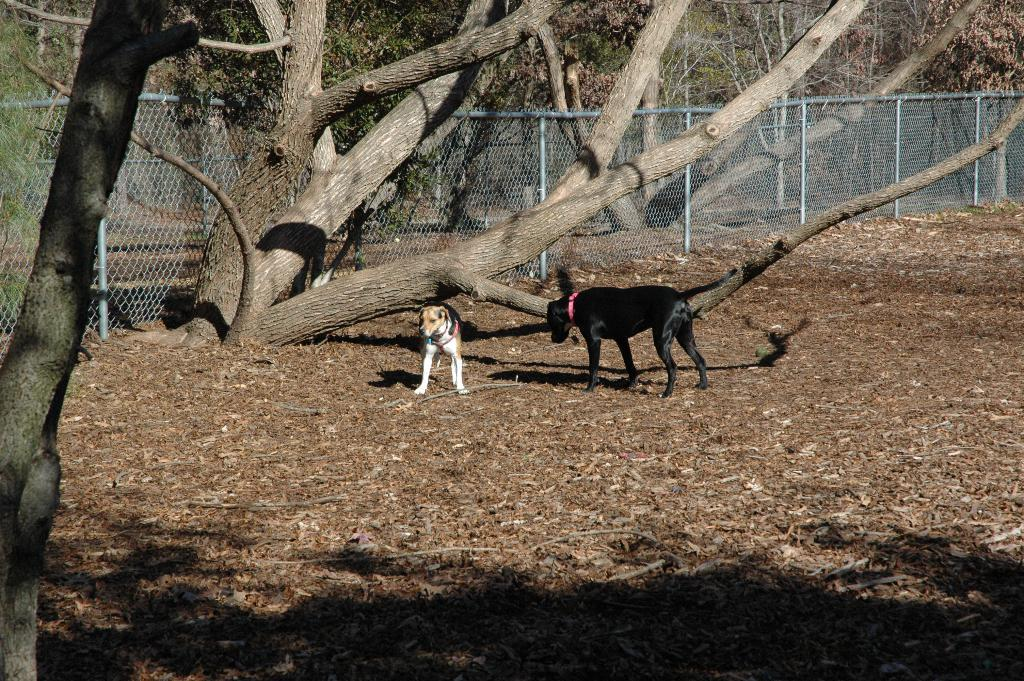What type of animals are in the image? There are dogs in the image. What can be seen in the background of the image? There are trees and a fence in the background of the image. What type of leather can be seen on the ground in the image? There is no leather visible on the ground in the image; it features dogs and a background with trees and a fence. 